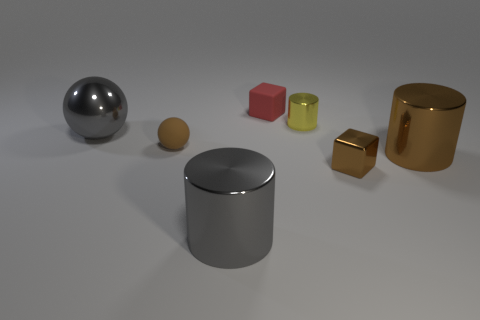What number of large things are both left of the tiny shiny cylinder and on the right side of the gray shiny ball?
Provide a succinct answer. 1. How many gray objects are either cylinders or large cylinders?
Provide a short and direct response. 1. What number of rubber things are either yellow objects or big brown spheres?
Offer a very short reply. 0. Are there any shiny objects?
Provide a short and direct response. Yes. Is the yellow thing the same shape as the tiny red rubber object?
Offer a very short reply. No. How many tiny yellow cylinders are on the right side of the big cylinder right of the metal cylinder that is on the left side of the tiny yellow shiny cylinder?
Provide a succinct answer. 0. The big object that is behind the brown shiny block and on the left side of the red object is made of what material?
Give a very brief answer. Metal. What color is the small object that is both behind the brown matte object and in front of the red thing?
Your answer should be compact. Yellow. Are there any other things that are the same color as the metal sphere?
Offer a very short reply. Yes. What is the shape of the gray thing that is in front of the big object that is to the right of the big cylinder to the left of the tiny metal block?
Your answer should be compact. Cylinder. 